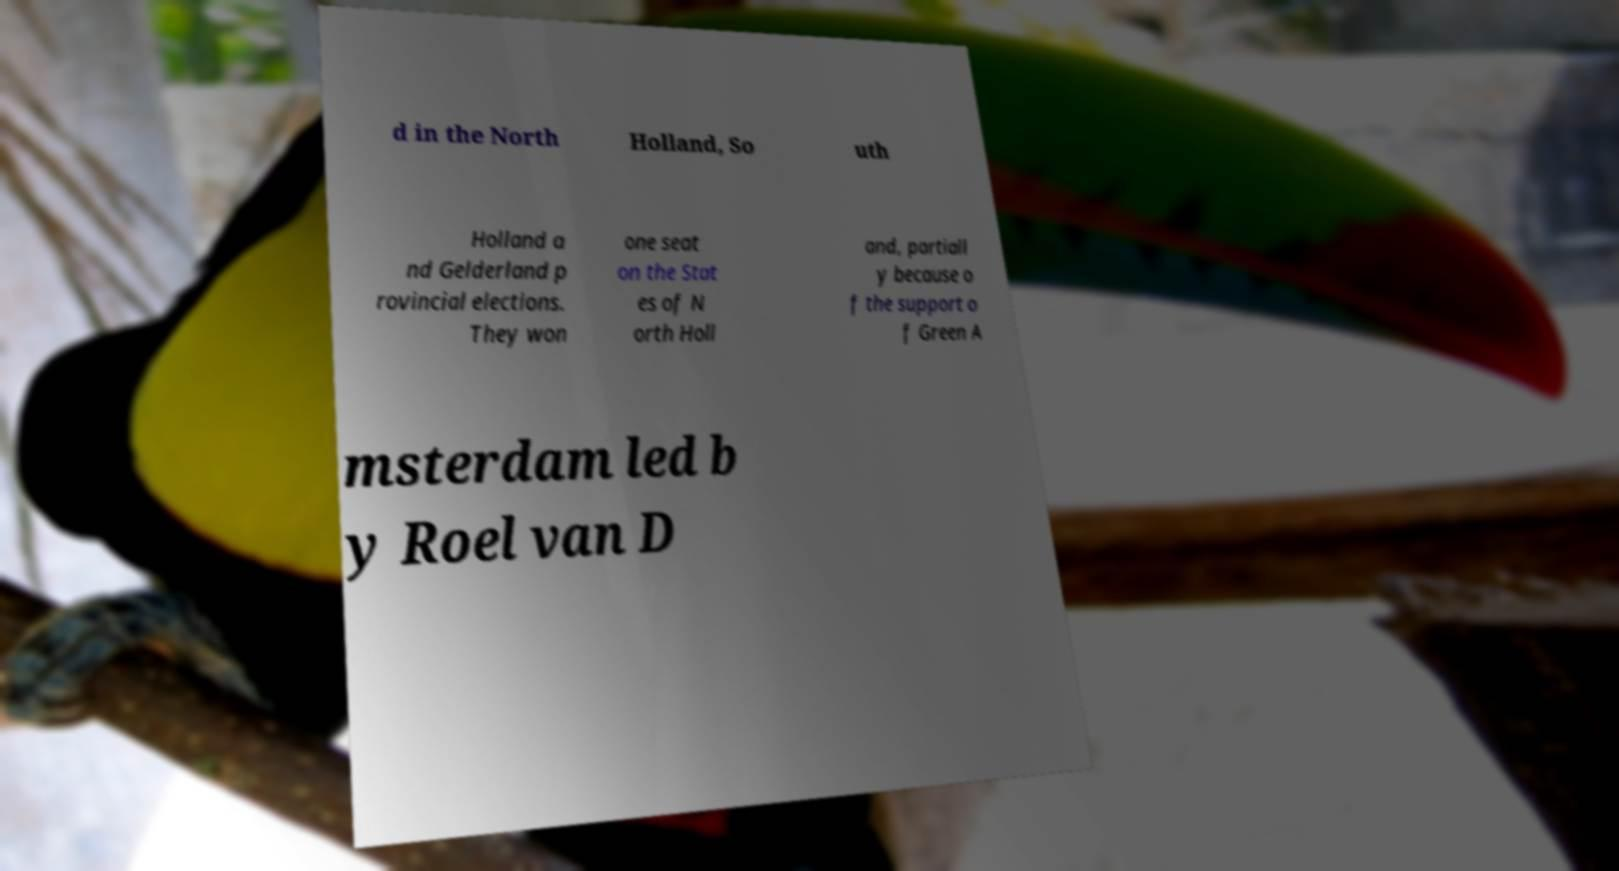Could you extract and type out the text from this image? d in the North Holland, So uth Holland a nd Gelderland p rovincial elections. They won one seat on the Stat es of N orth Holl and, partiall y because o f the support o f Green A msterdam led b y Roel van D 